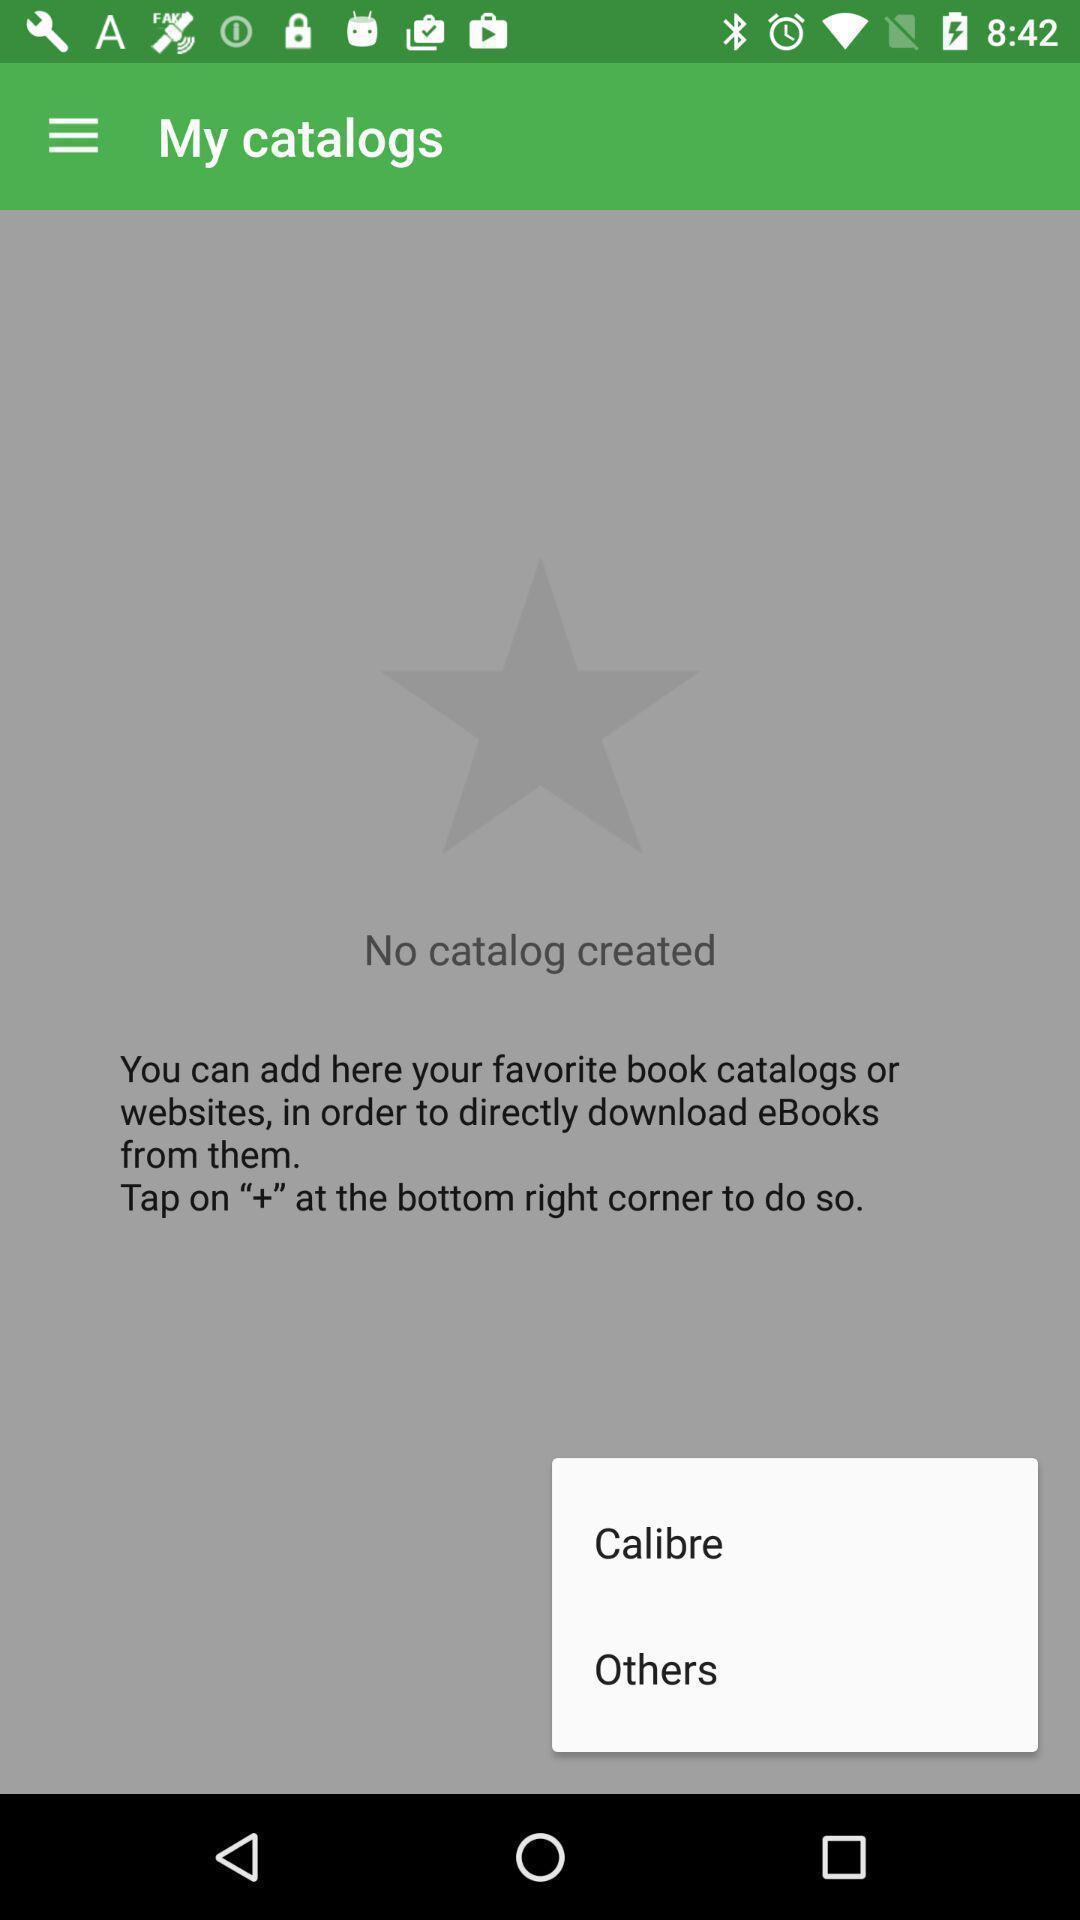Explain what's happening in this screen capture. Pop-up shows caliber and others. 